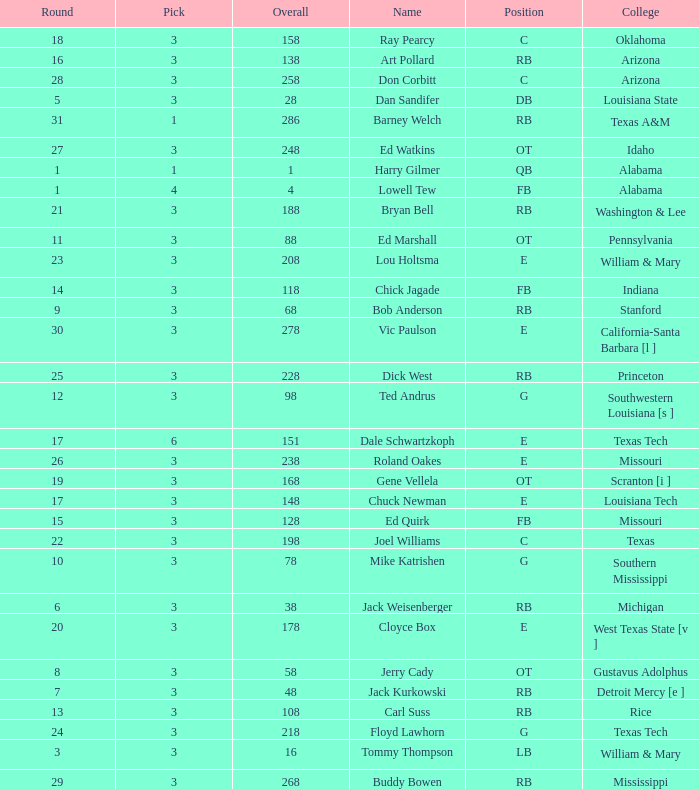What is stanford's average overall? 68.0. 